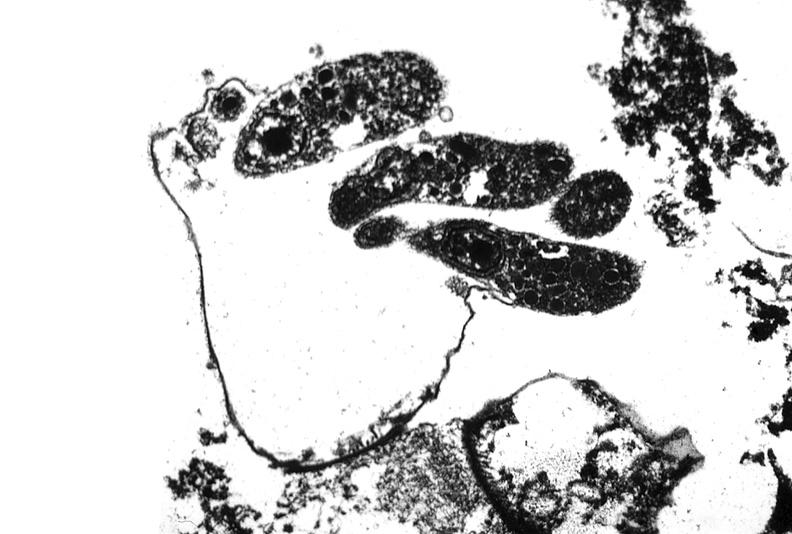what does this image show?
Answer the question using a single word or phrase. Colon biopsy 